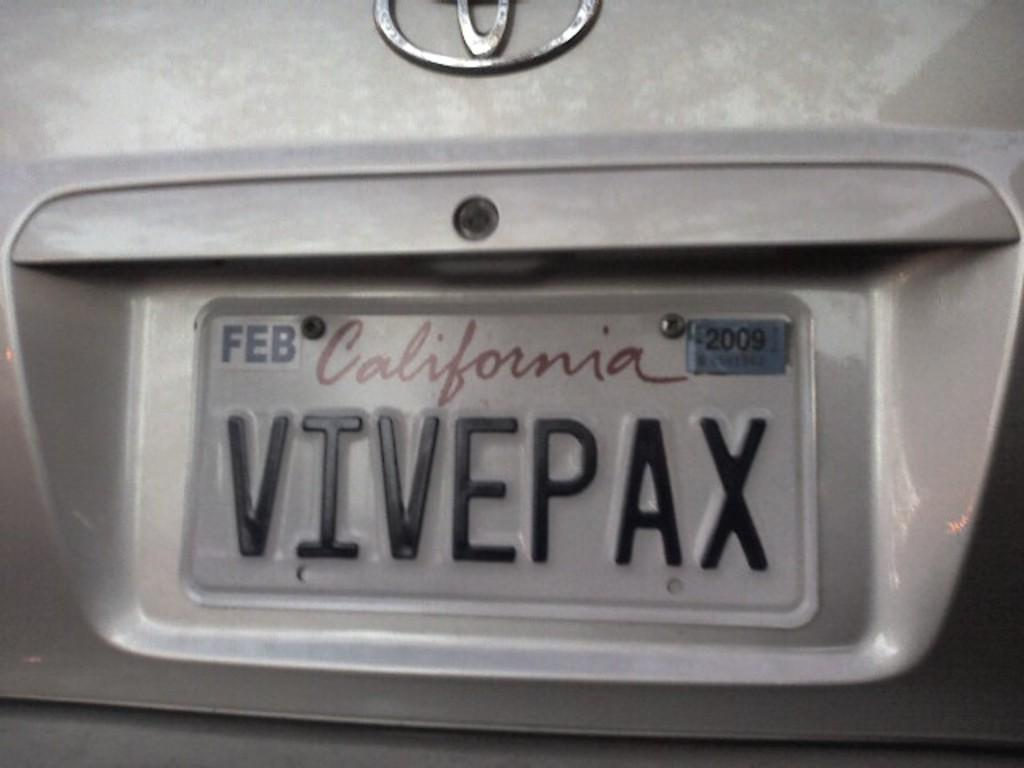<image>
Write a terse but informative summary of the picture. A Toyota car with a California tag that reads VIVEPAX. 